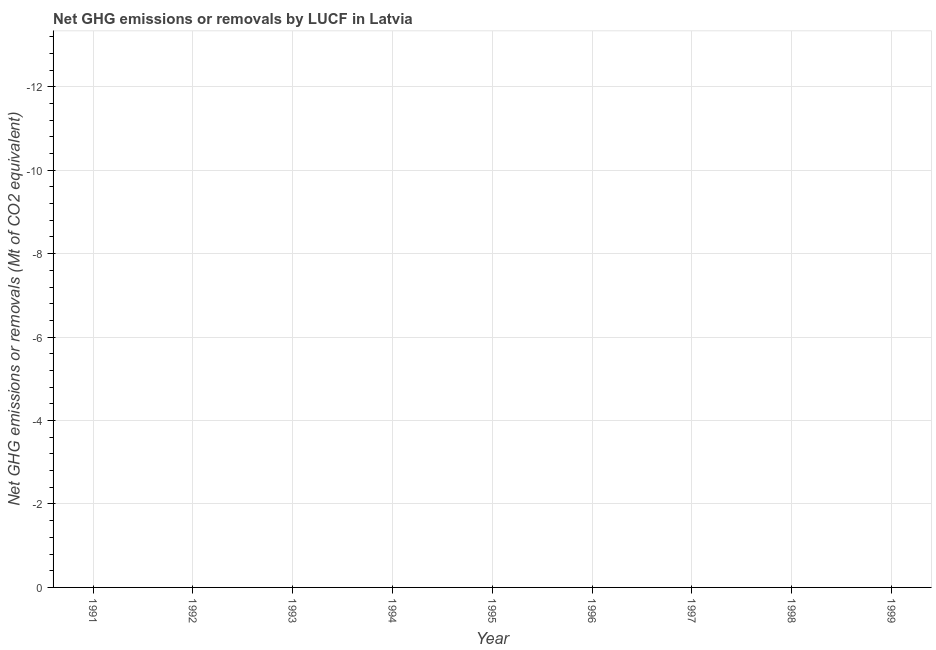What is the average ghg net emissions or removals per year?
Give a very brief answer. 0. What is the difference between two consecutive major ticks on the Y-axis?
Your answer should be very brief. 2. Are the values on the major ticks of Y-axis written in scientific E-notation?
Give a very brief answer. No. What is the title of the graph?
Provide a short and direct response. Net GHG emissions or removals by LUCF in Latvia. What is the label or title of the Y-axis?
Your answer should be compact. Net GHG emissions or removals (Mt of CO2 equivalent). What is the Net GHG emissions or removals (Mt of CO2 equivalent) in 1992?
Make the answer very short. 0. What is the Net GHG emissions or removals (Mt of CO2 equivalent) in 1993?
Keep it short and to the point. 0. What is the Net GHG emissions or removals (Mt of CO2 equivalent) in 1995?
Make the answer very short. 0. What is the Net GHG emissions or removals (Mt of CO2 equivalent) of 1998?
Your response must be concise. 0. What is the Net GHG emissions or removals (Mt of CO2 equivalent) of 1999?
Offer a very short reply. 0. 